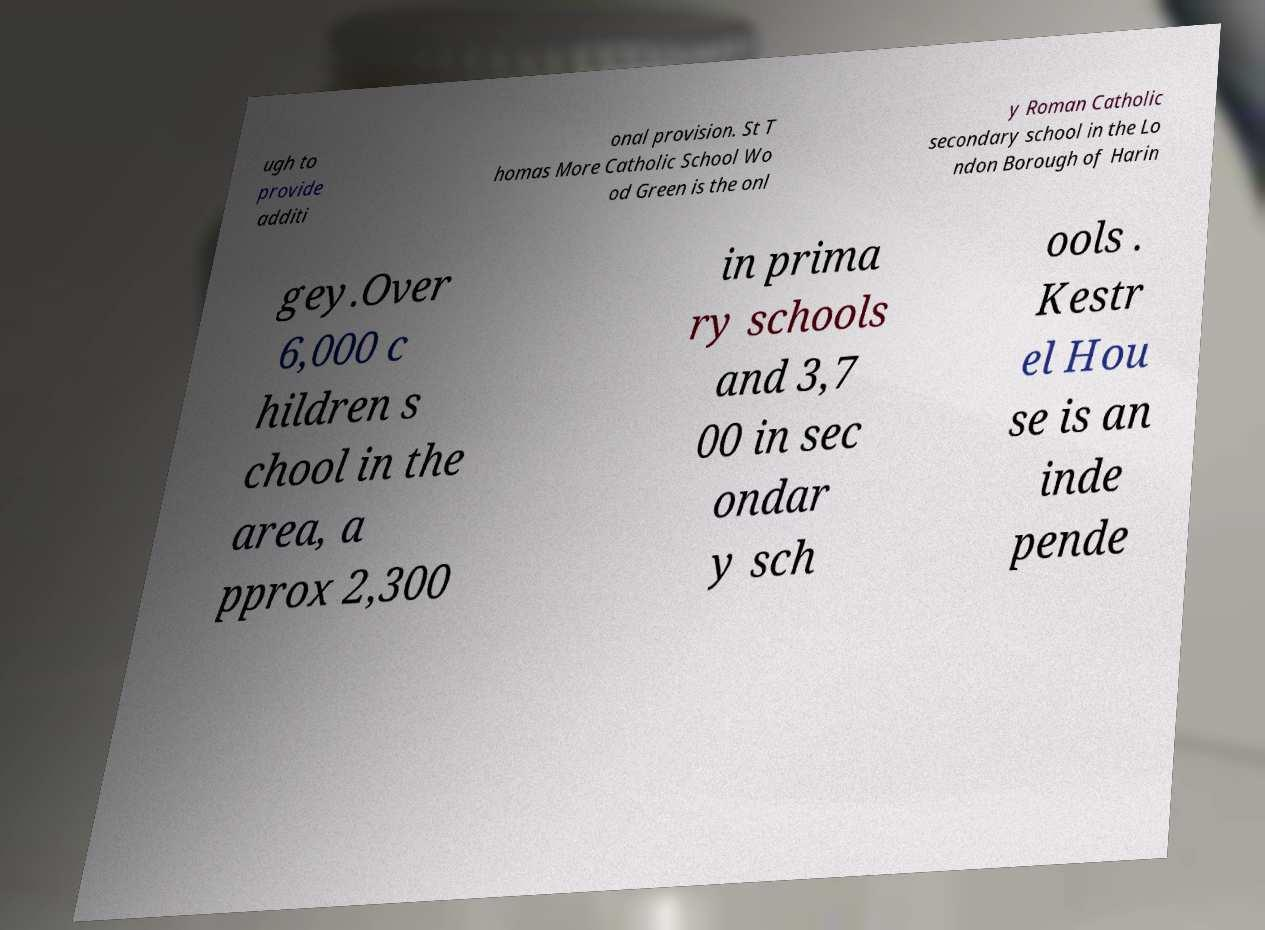Can you accurately transcribe the text from the provided image for me? ugh to provide additi onal provision. St T homas More Catholic School Wo od Green is the onl y Roman Catholic secondary school in the Lo ndon Borough of Harin gey.Over 6,000 c hildren s chool in the area, a pprox 2,300 in prima ry schools and 3,7 00 in sec ondar y sch ools . Kestr el Hou se is an inde pende 